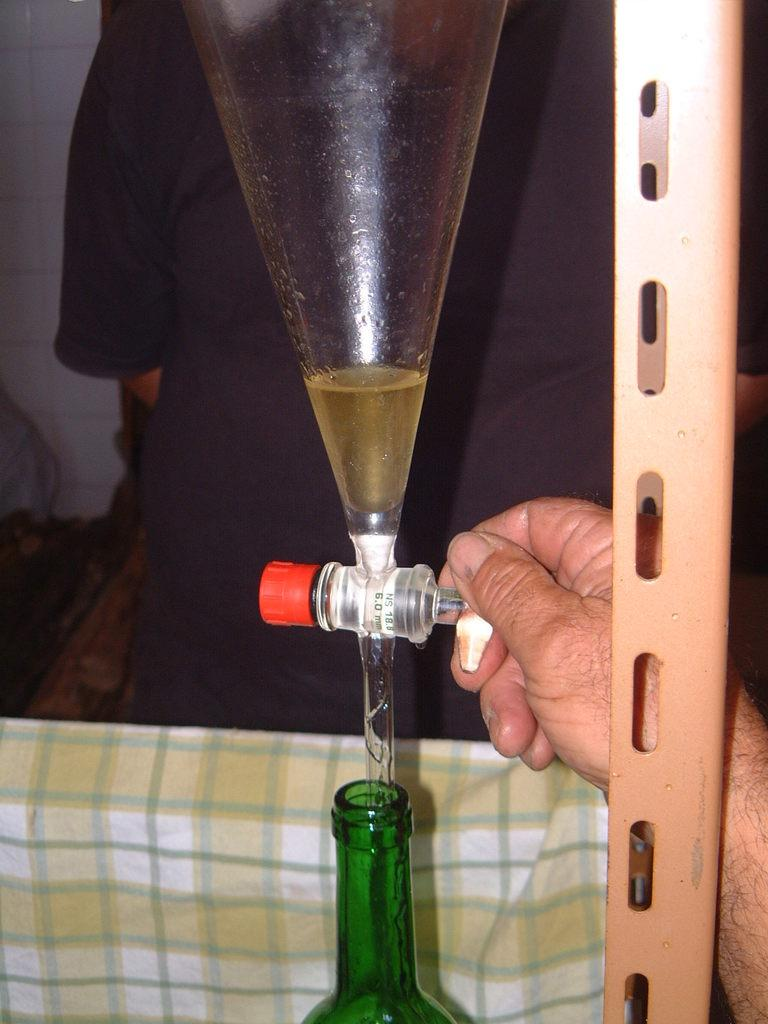What is being prepared in the image? Wine is being brewed into a bottle in the image. What tool is being used in the brewing process? A funnel is used in the brewing process. Can you describe the person involved in the process? There is a man holding the bottle or funnel in the image. What type of grass is growing on the light in the image? There is no light or grass present in the image; it features a man brewing wine using a funnel and a bottle. 